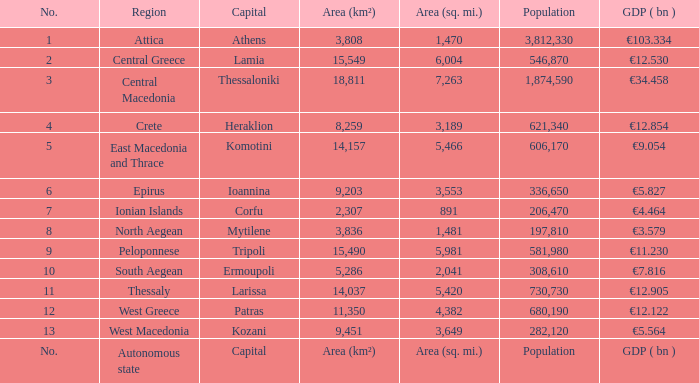In a place where the capital city is called capital, what is the gdp (bn)? GDP ( bn ). 